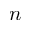<formula> <loc_0><loc_0><loc_500><loc_500>n</formula> 